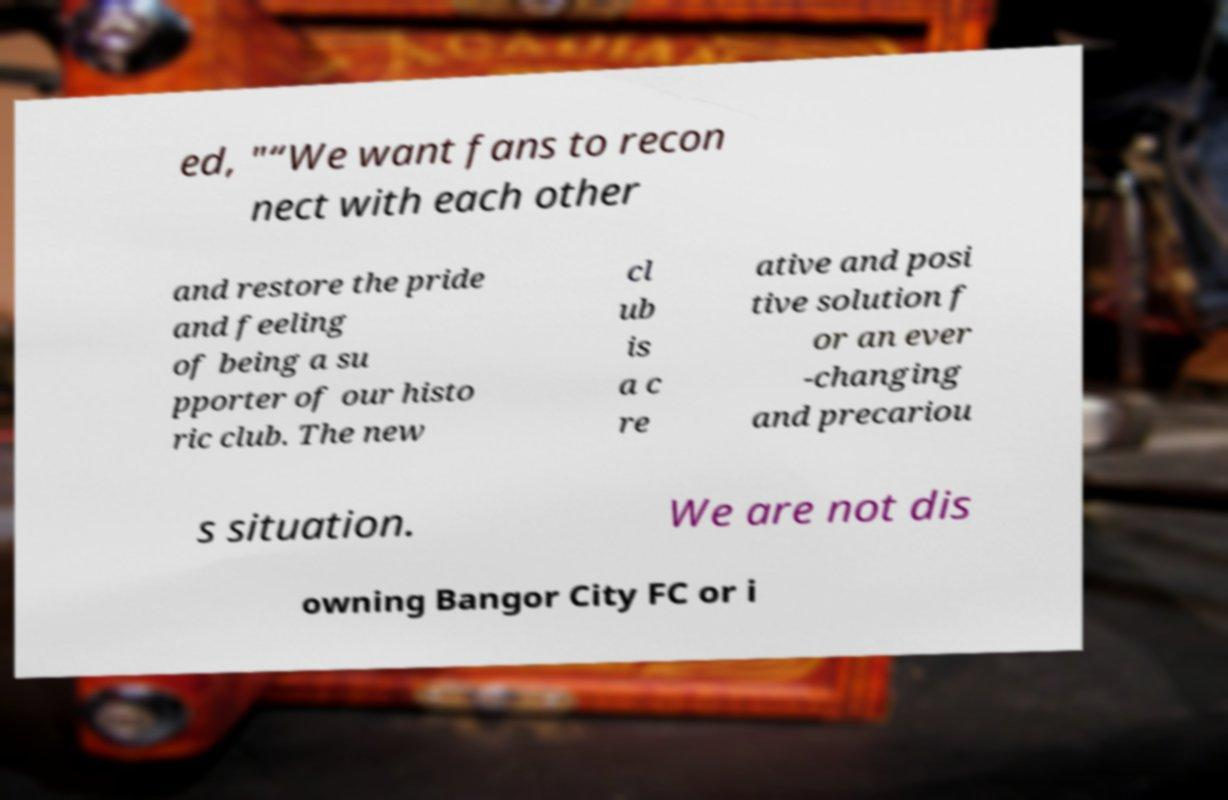Can you read and provide the text displayed in the image?This photo seems to have some interesting text. Can you extract and type it out for me? ed, "“We want fans to recon nect with each other and restore the pride and feeling of being a su pporter of our histo ric club. The new cl ub is a c re ative and posi tive solution f or an ever -changing and precariou s situation. We are not dis owning Bangor City FC or i 